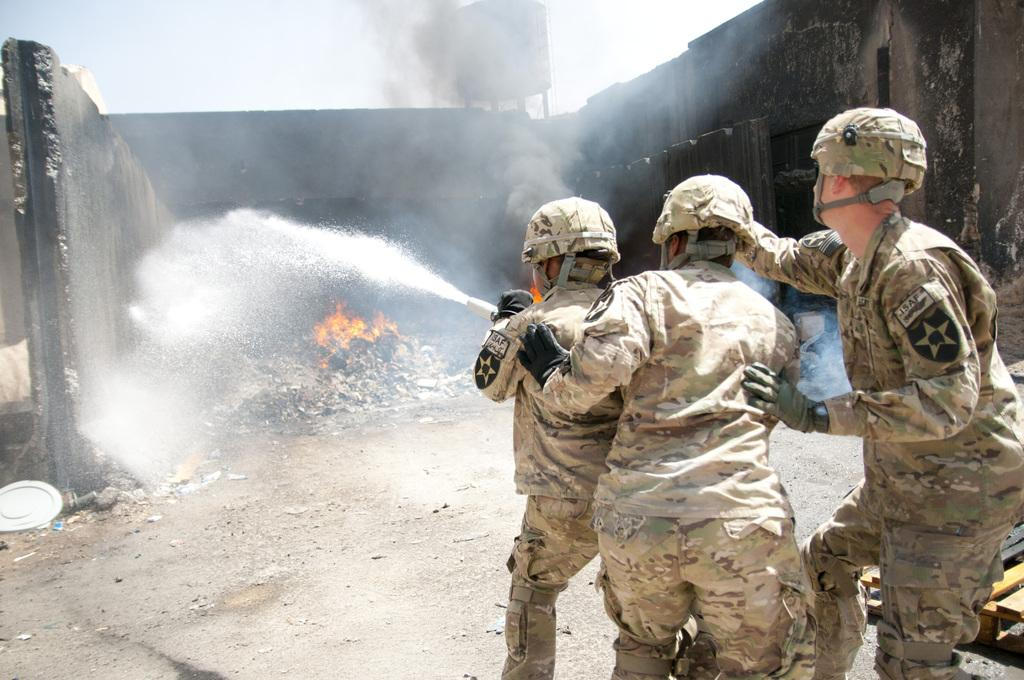How many people are on the right side of the image? There are three people on the right side of the image. What is visible in the image besides the people? Water, fire, walls, and the sky are visible in the image. What is the setting of the image? The image appears to be set near water, with walls and the sky visible in the background. What type of pickle is being used to extinguish the fire in the image? There is no pickle present in the image, and therefore it cannot be used to extinguish the fire. 